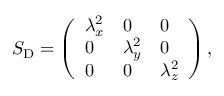Convert formula to latex. <formula><loc_0><loc_0><loc_500><loc_500>S _ { D } = \left ( \begin{array} { l l l } { \lambda _ { x } ^ { 2 } } & { 0 } & { 0 } \\ { 0 } & { \lambda _ { y } ^ { 2 } } & { 0 } \\ { 0 } & { 0 } & { \lambda _ { z } ^ { 2 } } \end{array} \right ) ,</formula> 